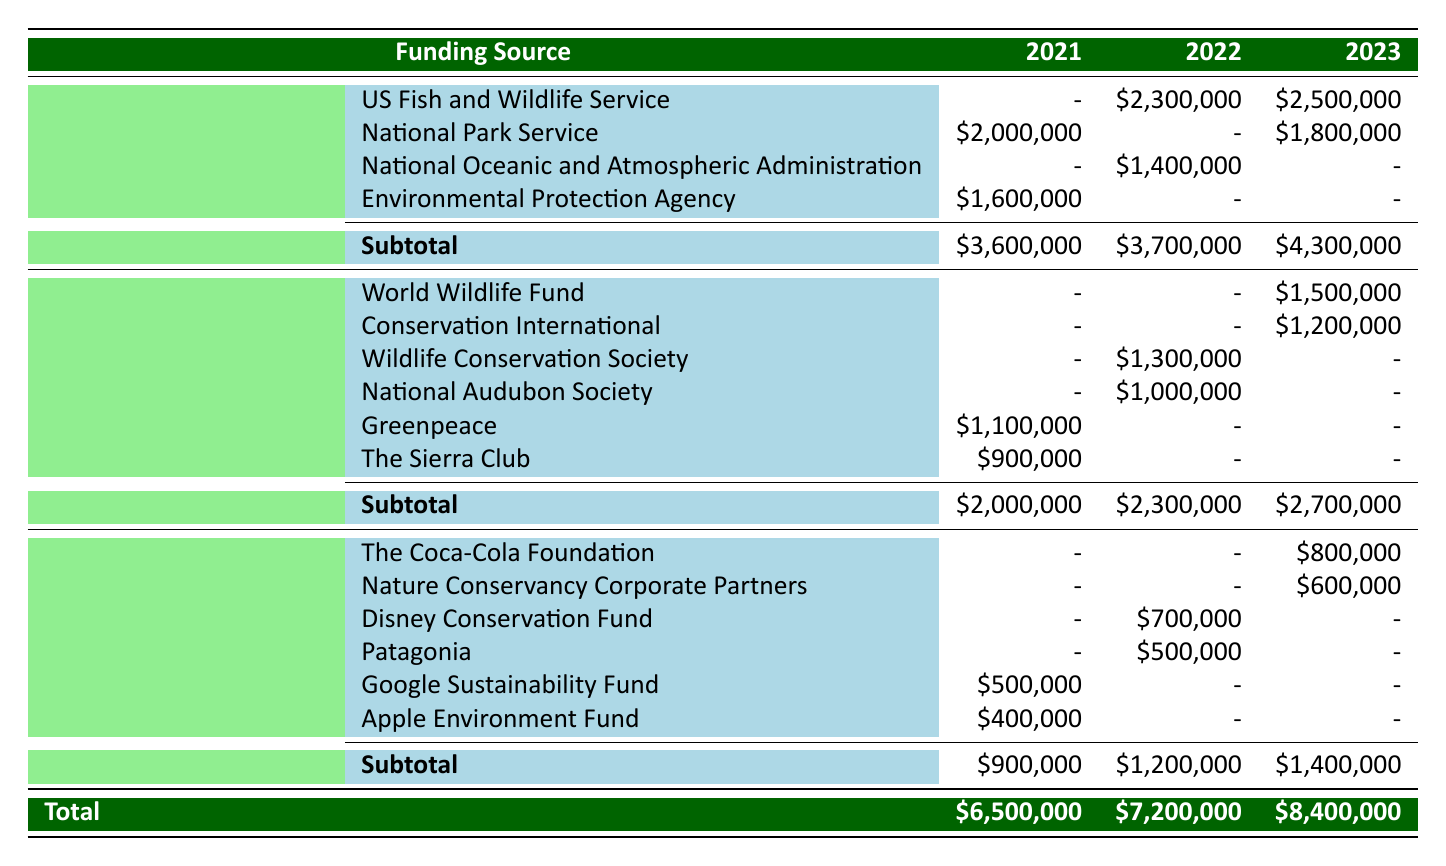What was the total funding from the Government in 2023? To find the total funding from the Government in 2023, I add the values from the Government sources listed for that year: US Fish and Wildlife Service ($2,500,000) + National Park Service ($1,800,000) = $4,300,000.
Answer: 4,300,000 Which private sector organization received the highest funding in 2022? Looking at the Private Sector row for 2022, I see that Disney Conservation Fund received $700,000, and Patagonia received $500,000. Therefore, Disney Conservation Fund received the highest funding.
Answer: Disney Conservation Fund What is the difference in total funding between 2021 and 2022? The total funding for 2021 is $6,500,000 and for 2022 is $7,200,000. To find the difference, I subtract 2021 from 2022: $7,200,000 - $6,500,000 = $700,000.
Answer: 700,000 Did any non-profit organization receive funding in every year from 2021 to 2023? I review the Non-Profit Organizations section for each year. Greenpeace and The Sierra Club received funding only in 2021, and no organization shows funding in all three years. Therefore, the answer is no.
Answer: No What was the average funding for Non-Profit Organizations across the years? I calculate the total funding for Non-Profit Organizations over the three years. In 2021, it was $2,000,000, in 2022 it was $2,300,000, and in 2023 it was $2,700,000. Total = $2,000,000 + $2,300,000 + $2,700,000 = $7,000,000. Since there are three years, I divide by 3: $7,000,000 / 3 = $2,333,333.33.
Answer: 2,333,333.33 Which year saw the highest total funding across all sources? I look at the Total funding row for each year: 2021 ($6,500,000), 2022 ($7,200,000), and 2023 ($8,400,000). The highest total is in 2023 at $8,400,000.
Answer: 2023 